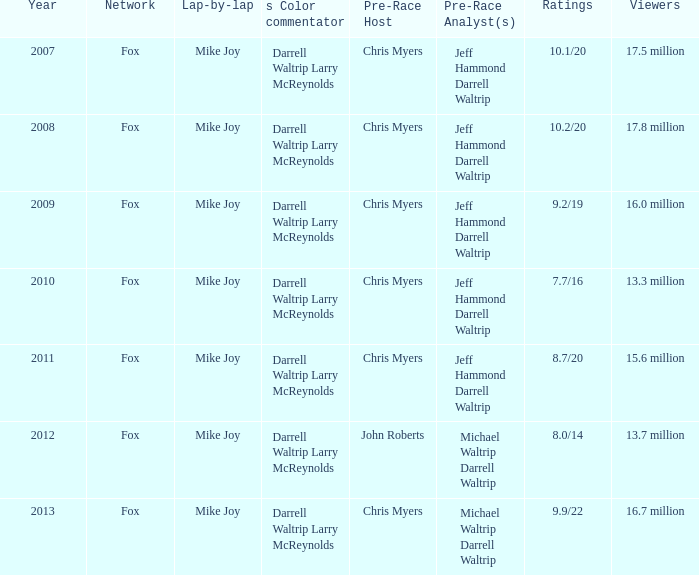How many assessments did the 2013 year have? 9.9/22. 